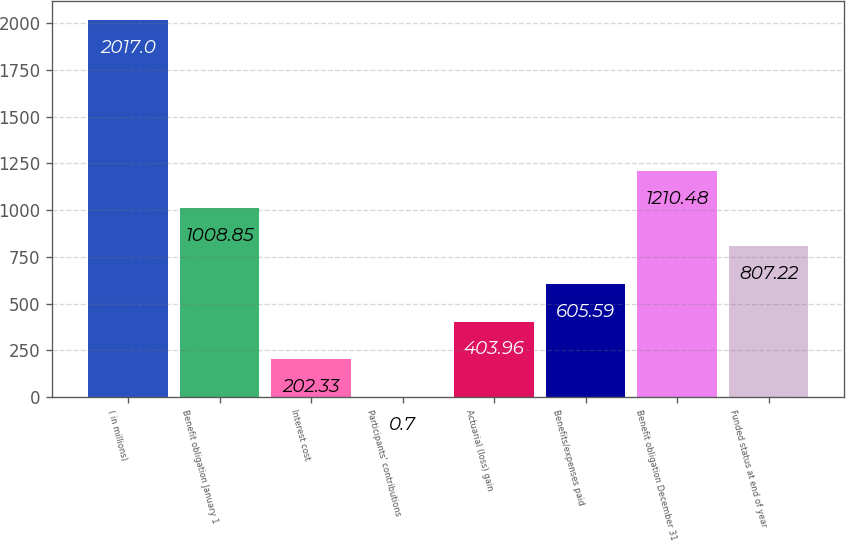Convert chart. <chart><loc_0><loc_0><loc_500><loc_500><bar_chart><fcel>( in millions)<fcel>Benefit obligation January 1<fcel>Interest cost<fcel>Participants' contributions<fcel>Actuarial (loss) gain<fcel>Benefits/expenses paid<fcel>Benefit obligation December 31<fcel>Funded status at end of year<nl><fcel>2017<fcel>1008.85<fcel>202.33<fcel>0.7<fcel>403.96<fcel>605.59<fcel>1210.48<fcel>807.22<nl></chart> 